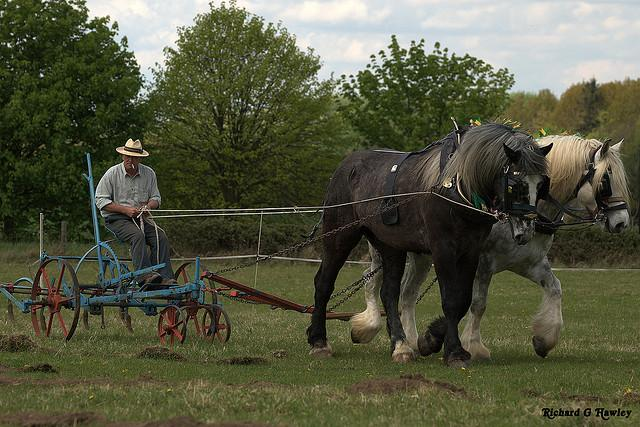What is he doing?

Choices:
A) smoking cigarette
B) plowing field
C) stealing horsed
D) feeding horsed plowing field 